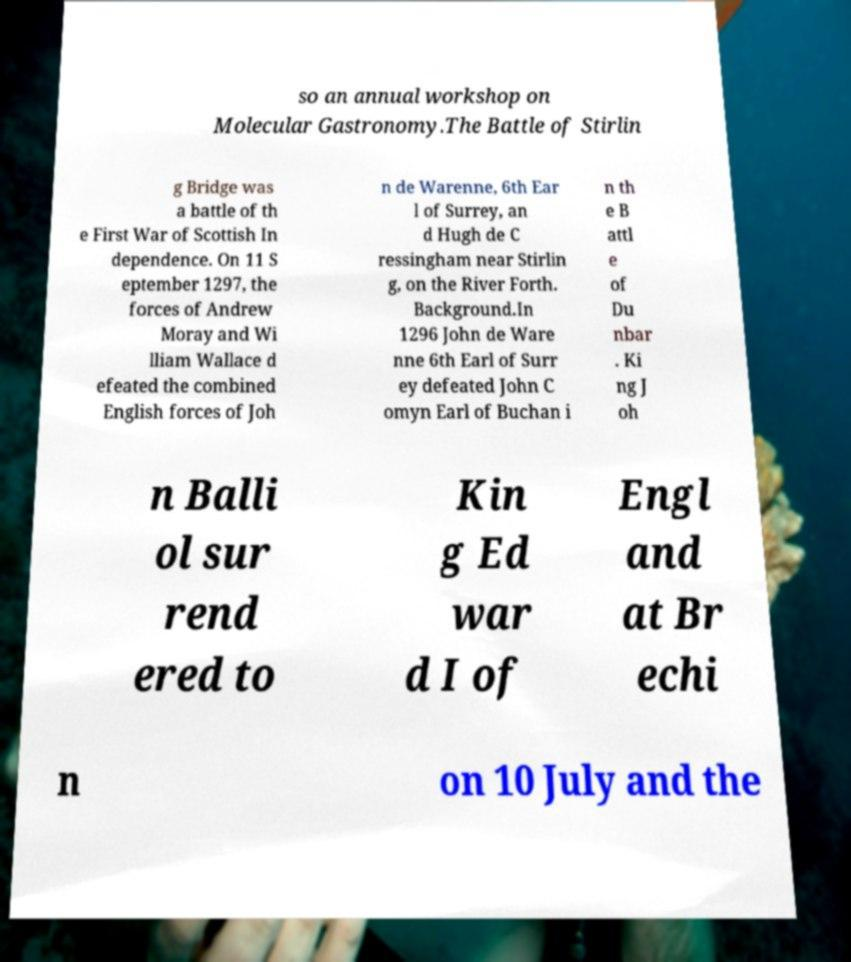There's text embedded in this image that I need extracted. Can you transcribe it verbatim? so an annual workshop on Molecular Gastronomy.The Battle of Stirlin g Bridge was a battle of th e First War of Scottish In dependence. On 11 S eptember 1297, the forces of Andrew Moray and Wi lliam Wallace d efeated the combined English forces of Joh n de Warenne, 6th Ear l of Surrey, an d Hugh de C ressingham near Stirlin g, on the River Forth. Background.In 1296 John de Ware nne 6th Earl of Surr ey defeated John C omyn Earl of Buchan i n th e B attl e of Du nbar . Ki ng J oh n Balli ol sur rend ered to Kin g Ed war d I of Engl and at Br echi n on 10 July and the 